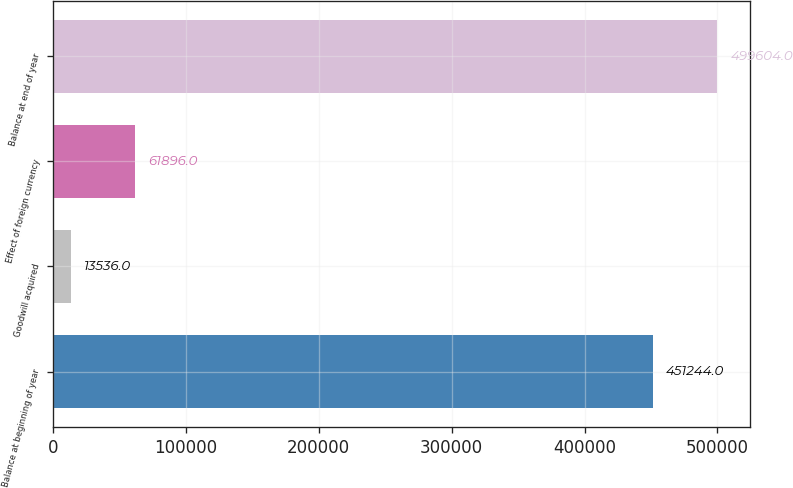<chart> <loc_0><loc_0><loc_500><loc_500><bar_chart><fcel>Balance at beginning of year<fcel>Goodwill acquired<fcel>Effect of foreign currency<fcel>Balance at end of year<nl><fcel>451244<fcel>13536<fcel>61896<fcel>499604<nl></chart> 